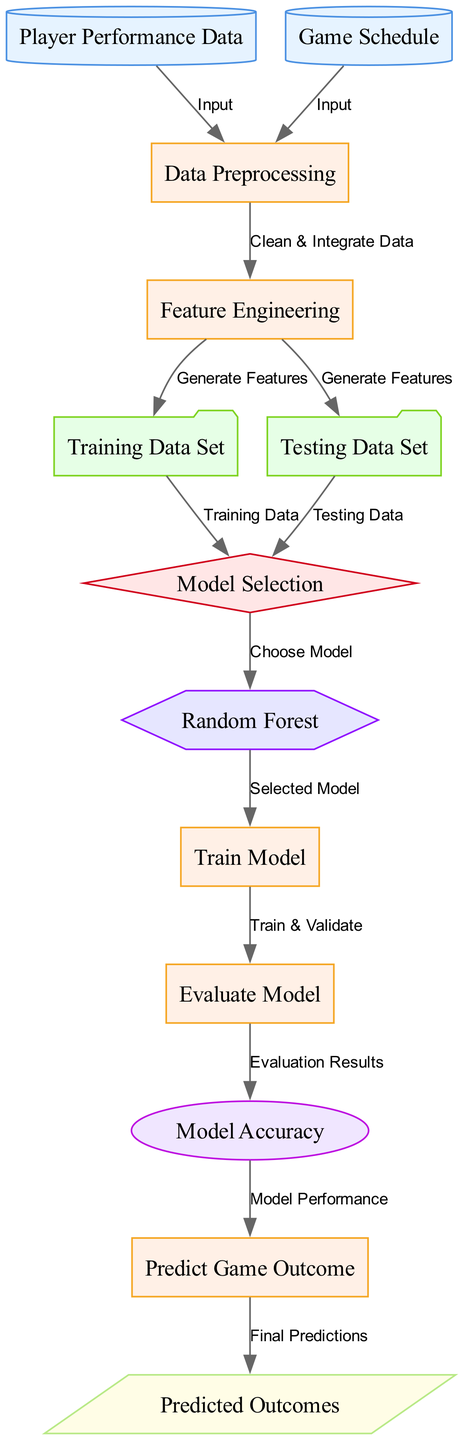What is the first step in the diagram? The first step involves 'Player Performance Data' and 'Game Schedule', both of which are inputs to the 'Data Preprocessing' node. Hence, Data Preprocessing is the first process step initiated from the input data.
Answer: Data Preprocessing What type of node is 'Random Forest'? 'Random Forest' is categorized as a model in the diagram, indicated by its hexagonal shape and label.
Answer: model How many data sets are shown in the diagram? The diagram features two data sets: 'Training Data Set' and 'Testing Data Set', both of which are represented as separate nodes.
Answer: two Which process follows 'Feature Engineering' in the diagram? From 'Feature Engineering', the diagram directs to two nodes: 'Training Data Set' and 'Testing Data Set', indicating that features generated can be used for both training and testing. Hence, after engineering features, these two data sets are the next steps.
Answer: Training Data Set and Testing Data Set What is the output of the diagram? The output of the diagram is 'Predicted Outcomes', which is the final result derived after the 'Predict Game Outcome' process.
Answer: Predicted Outcomes What model is selected for the prediction? The diagram specifies 'Random Forest' as the chosen model for making predictions.
Answer: Random Forest What is evaluated after the model is trained? After the model is trained, the next step in the diagram is to 'Evaluate Model', which assesses the model's performance.
Answer: Evaluate Model How does 'Game Schedule' relate to 'Data Preprocessing'? 'Game Schedule' is an input, alongside 'Player Performance Data', that feeds into 'Data Preprocessing'. This indicates that the game schedule is utilized to prepare the data for analysis.
Answer: Input What metric is used to assess model performance? The metric used to assess model performance in the diagram is 'Model Accuracy', which derives from the evaluation results of the trained model.
Answer: Model Accuracy 